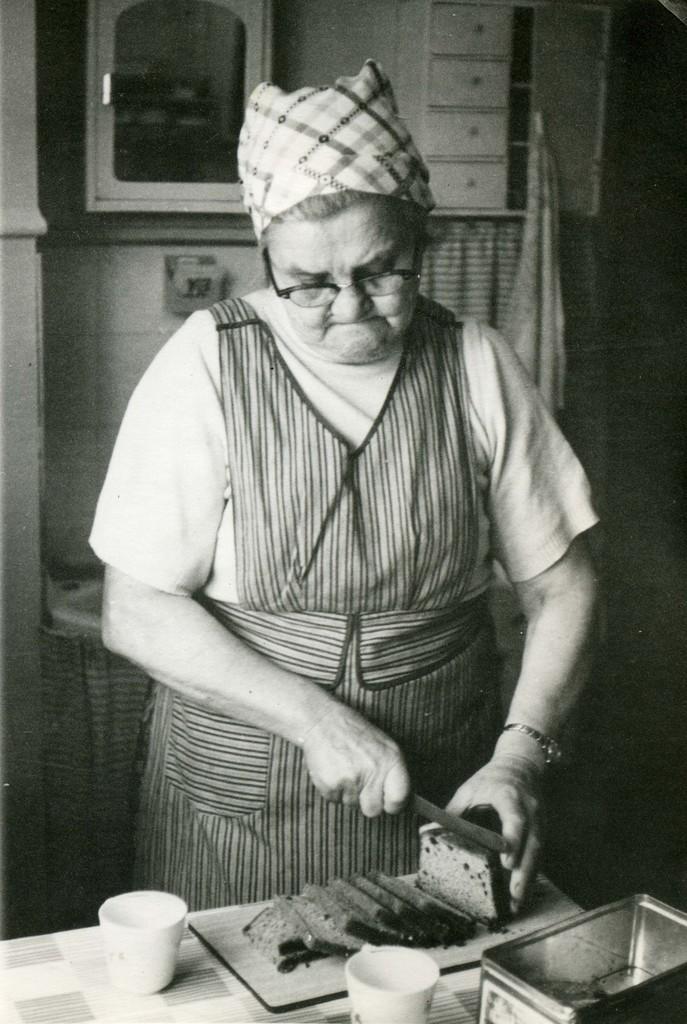Could you give a brief overview of what you see in this image? This is a black and white picture. In the background we can see cupboards, cloth and an object. In this picture we can see a woman wearing spectacles. She is holding a knife and bread. We can see bread slices on the chopping board. On the platform we can see cups and a container. 